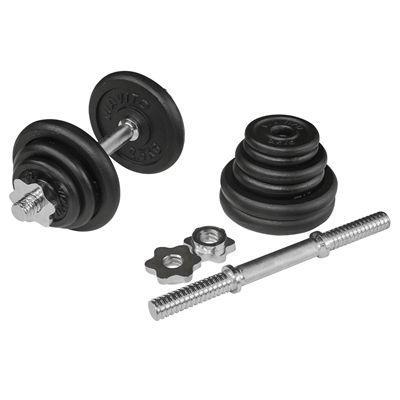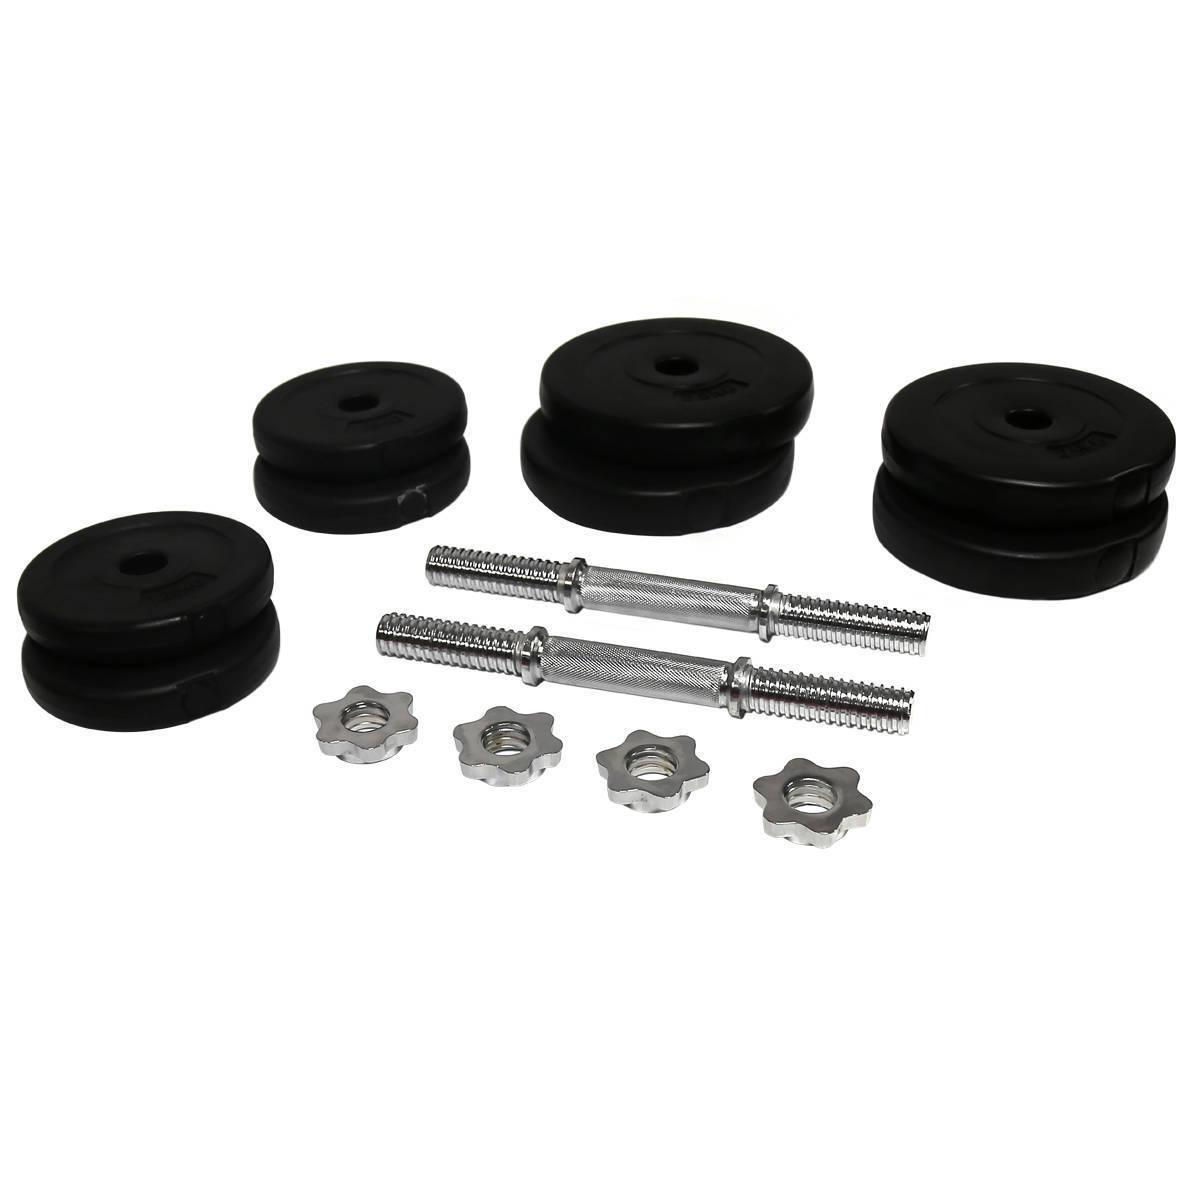The first image is the image on the left, the second image is the image on the right. For the images displayed, is the sentence "Both images include separate dumbbell parts that require assembly." factually correct? Answer yes or no. Yes. The first image is the image on the left, the second image is the image on the right. Examine the images to the left and right. Is the description "The right image contains the disassembled parts for two barbells." accurate? Answer yes or no. Yes. 